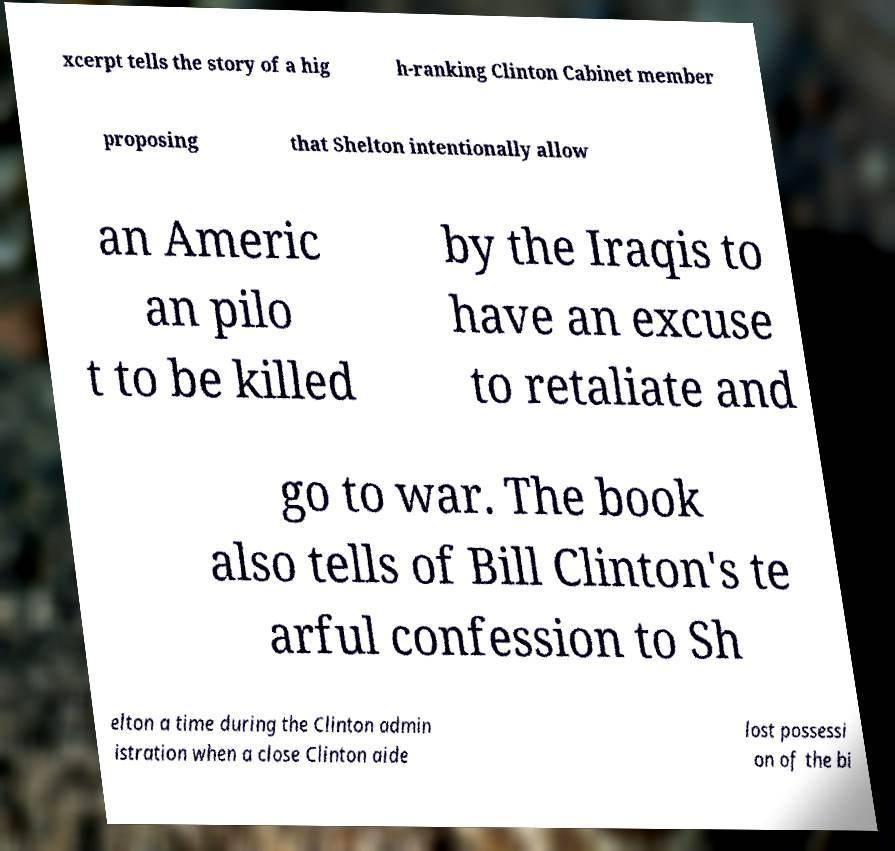What messages or text are displayed in this image? I need them in a readable, typed format. xcerpt tells the story of a hig h-ranking Clinton Cabinet member proposing that Shelton intentionally allow an Americ an pilo t to be killed by the Iraqis to have an excuse to retaliate and go to war. The book also tells of Bill Clinton's te arful confession to Sh elton a time during the Clinton admin istration when a close Clinton aide lost possessi on of the bi 